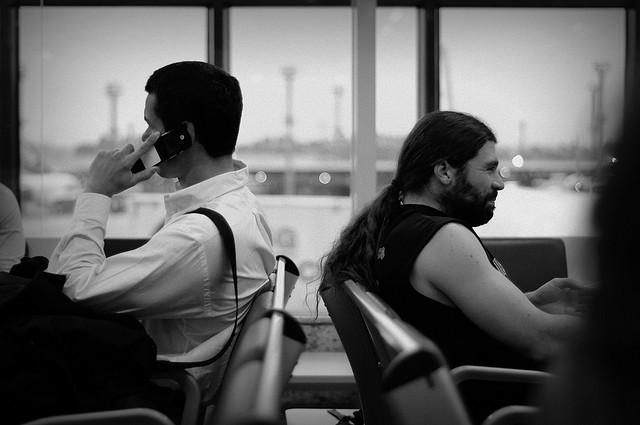What is on the man's face?
Concise answer only. Beard. What color is the cell phone?
Quick response, please. Black. What is on the face of the man to the right?
Be succinct. Beard. Do they match?
Short answer required. No. Where are these people?
Concise answer only. Airport. Do these men know each other?
Give a very brief answer. No. Are these men together?
Quick response, please. No. Is the man right handed?
Answer briefly. No. 